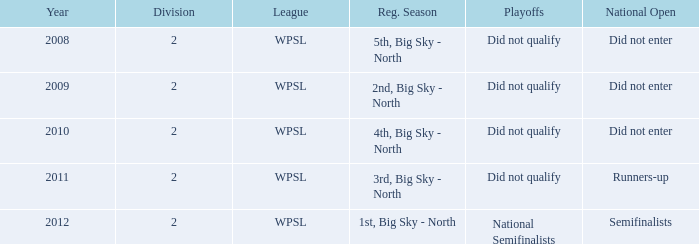What league was involved in 2008? WPSL. Could you help me parse every detail presented in this table? {'header': ['Year', 'Division', 'League', 'Reg. Season', 'Playoffs', 'National Open'], 'rows': [['2008', '2', 'WPSL', '5th, Big Sky - North', 'Did not qualify', 'Did not enter'], ['2009', '2', 'WPSL', '2nd, Big Sky - North', 'Did not qualify', 'Did not enter'], ['2010', '2', 'WPSL', '4th, Big Sky - North', 'Did not qualify', 'Did not enter'], ['2011', '2', 'WPSL', '3rd, Big Sky - North', 'Did not qualify', 'Runners-up'], ['2012', '2', 'WPSL', '1st, Big Sky - North', 'National Semifinalists', 'Semifinalists']]} 